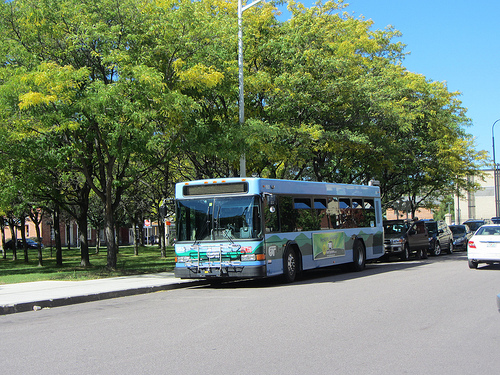Let's imagine a fantastical scenario involving the bus. Imagine this bus is part of a magical transportation system in a city where each bus has a unique ability. This bus, for instance, can travel through time. It whisks its passengers to different eras, allowing them to witness historical events, meet legendary figures, and experience life in different centuries. Passengers could board the bus today and find themselves stepping off in ancient Rome, the Renaissance, or even a futuristic city. This extraordinary bus would thus serve as a bridge between past, present, and future, offering an unprecedented journey through the corridors of time. 